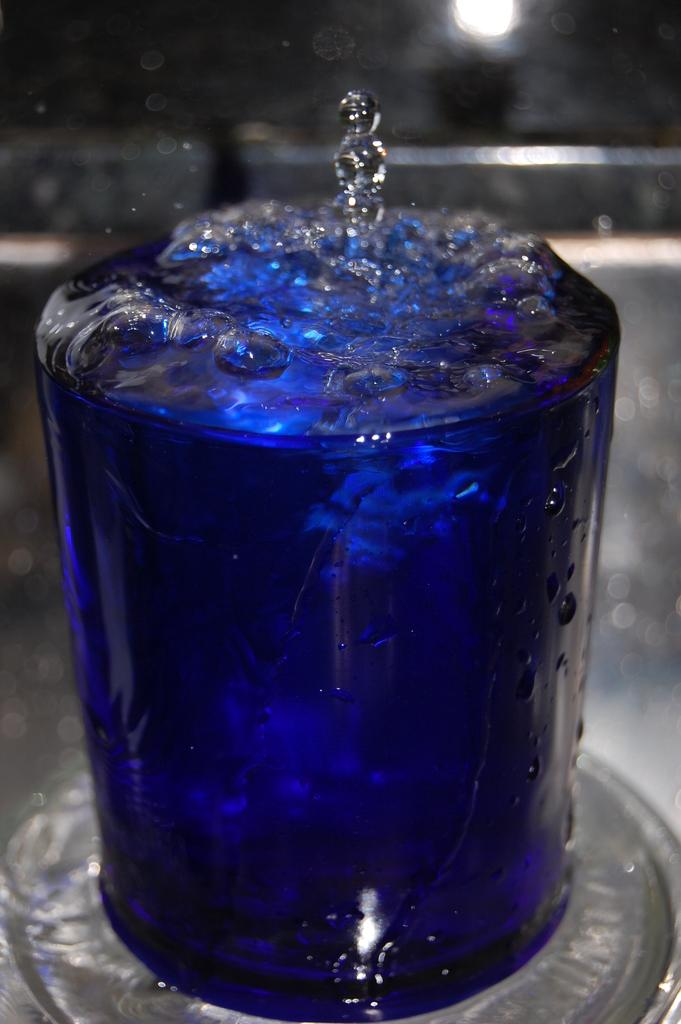What is in the glass that is visible in the image? The glass contains a blue drink. What is a notable characteristic of the drink in the glass? The drink has bubbles. Where is the glass placed in the image? The glass is placed on a surface. How many mice are sitting on the rim of the glass in the image? There are no mice present in the image. What type of horn is attached to the glass in the image? There is no horn attached to the glass in the image. 